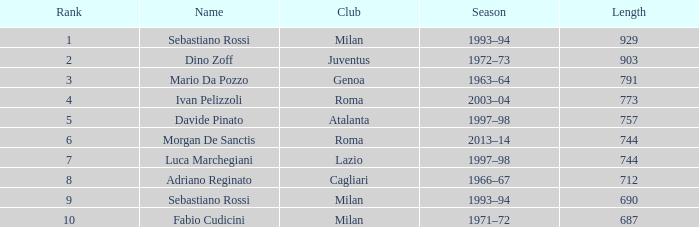What is the name for a length exceeding 903? Sebastiano Rossi. 